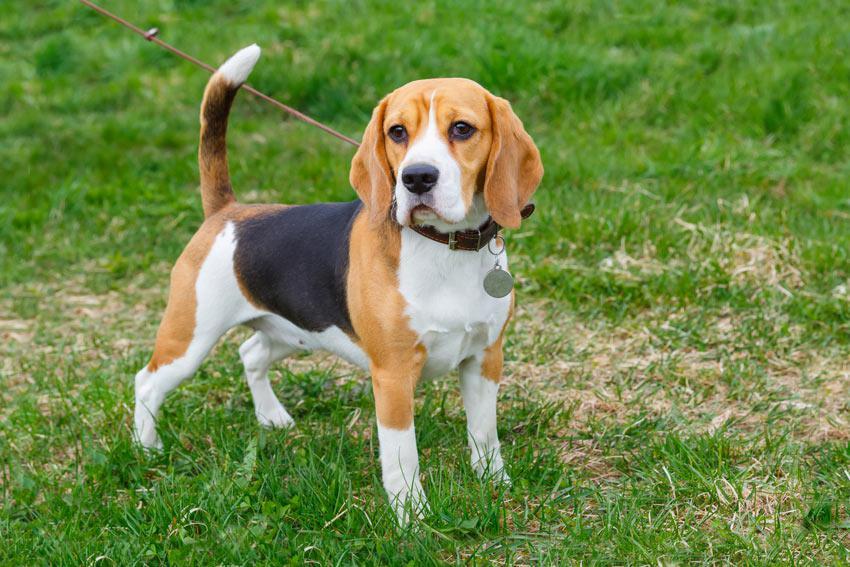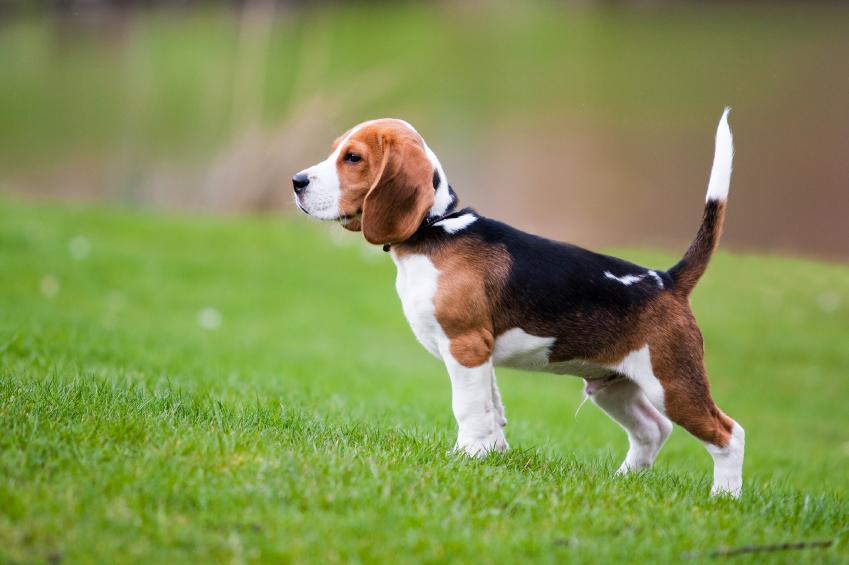The first image is the image on the left, the second image is the image on the right. Considering the images on both sides, is "There are no more than two animals" valid? Answer yes or no. Yes. 